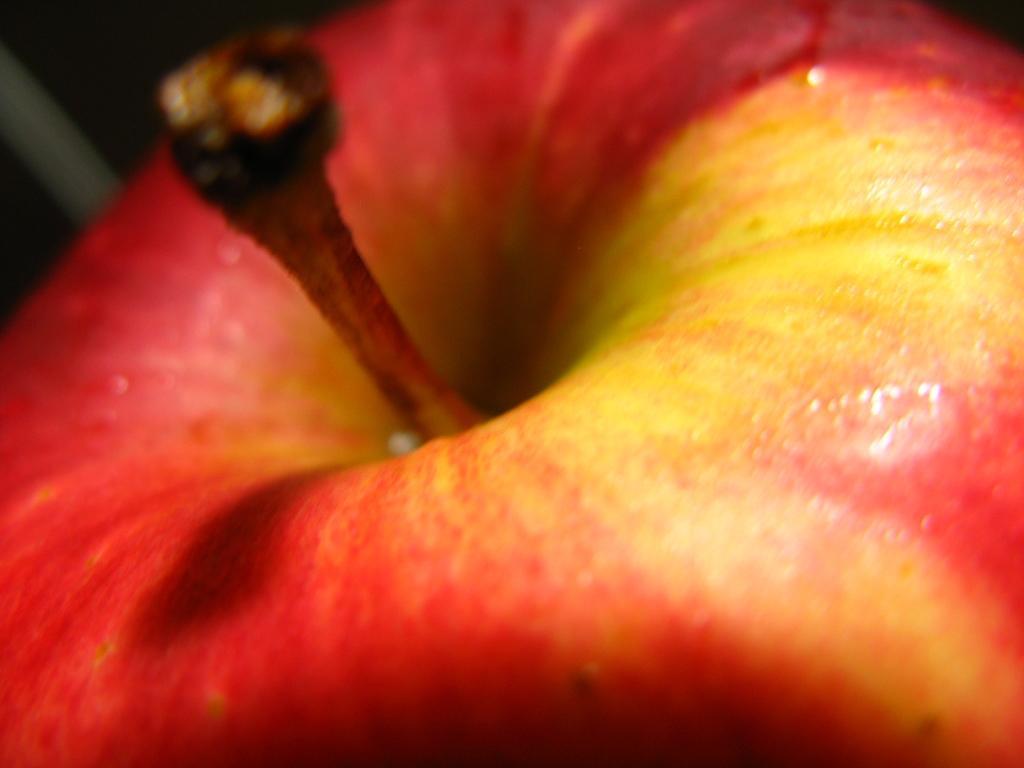Could you give a brief overview of what you see in this image? In the picture we can see an apple which is red in color and some part yellow in color. 